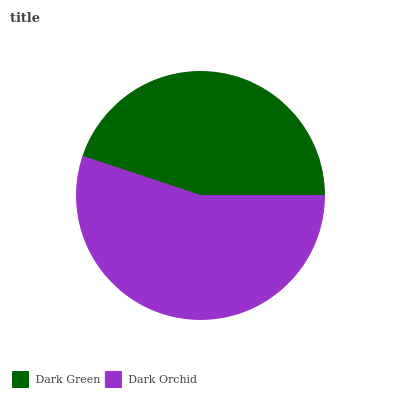Is Dark Green the minimum?
Answer yes or no. Yes. Is Dark Orchid the maximum?
Answer yes or no. Yes. Is Dark Orchid the minimum?
Answer yes or no. No. Is Dark Orchid greater than Dark Green?
Answer yes or no. Yes. Is Dark Green less than Dark Orchid?
Answer yes or no. Yes. Is Dark Green greater than Dark Orchid?
Answer yes or no. No. Is Dark Orchid less than Dark Green?
Answer yes or no. No. Is Dark Orchid the high median?
Answer yes or no. Yes. Is Dark Green the low median?
Answer yes or no. Yes. Is Dark Green the high median?
Answer yes or no. No. Is Dark Orchid the low median?
Answer yes or no. No. 